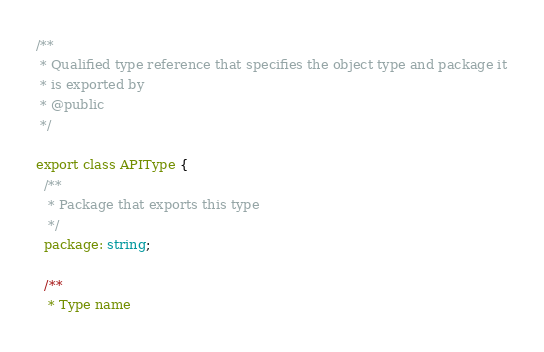Convert code to text. <code><loc_0><loc_0><loc_500><loc_500><_TypeScript_>/**
 * Qualified type reference that specifies the object type and package it
 * is exported by
 * @public
 */

export class APIType {
  /**
   * Package that exports this type
   */
  package: string;

  /**
   * Type name</code> 